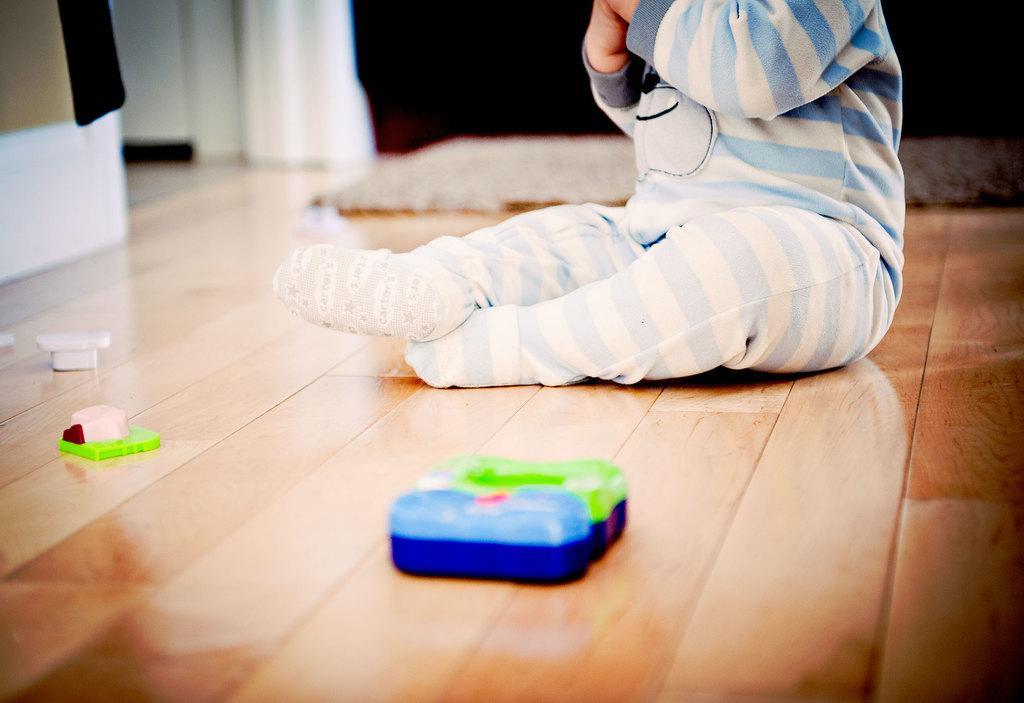In one or two sentences, can you explain what this image depicts? This image is taken indoors. At the bottom of the image there is a floor. In the background there is a wall. There is a curtain and there is a mat on the floor. In the middle of the image a baby is sitting on the floor and there are a few toys on the floor. On the left side of the image there is an object. 